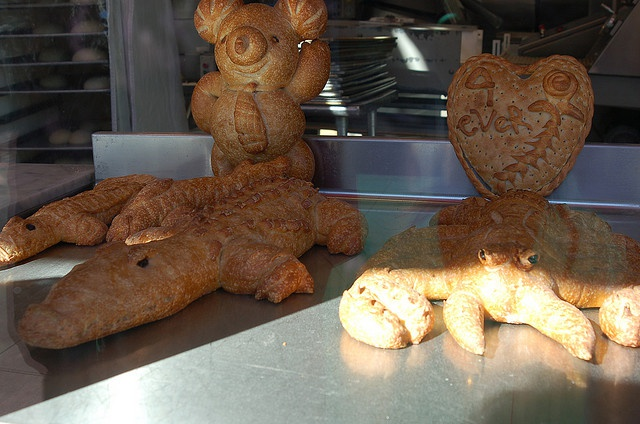Describe the objects in this image and their specific colors. I can see a teddy bear in black, maroon, brown, and gray tones in this image. 